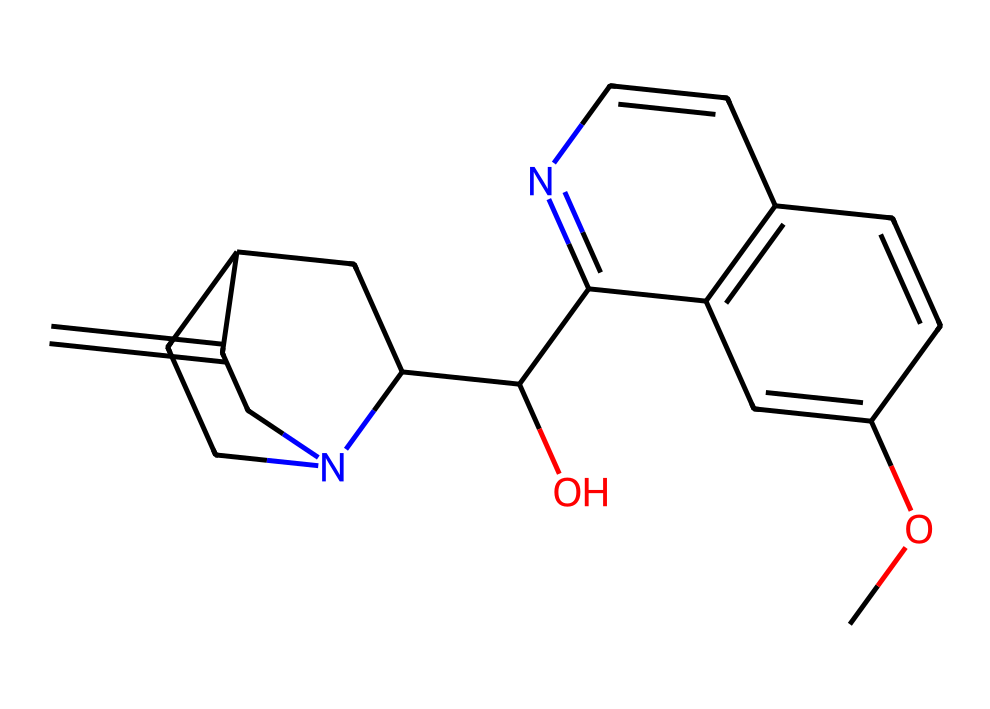What is the molecular formula for quinine? To find the molecular formula, we analyze the structure represented by the SMILES notation and count the number of each type of atom present in the molecule. The molecular formula of quinine is C20H24N2O2, which includes 20 carbon atoms, 24 hydrogen atoms, 2 nitrogen atoms, and 2 oxygen atoms.
Answer: C20H24N2O2 How many rings are present in the quinine structure? By examining the structure, we can identify the cyclic parts of the molecule. The SMILES indicates two distinct ring structures in quinine, which can be counted from the notation providing insight into its cyclic nature.
Answer: 2 What functional group is primarily responsible for quinine's bitterness? The presence of the nitrogen atom in the structure, characteristic of alkaloids, indicates the formation of a basic functional group that contributes to the bitterness of quinine.
Answer: Nitrogen What element is found in quinine that contributes to its pharmacological properties? In analyzing the structural formula through the SMILES representation, the nitrogen atoms play a critical role in its biological activity, affecting how quinine interacts with biological systems.
Answer: Nitrogen Which part of the molecule may enhance the solubility of quinine in beverages? The hydroxyl group (-OH) present in the molecular composition can significantly enhance solubility in polar solvents, enhancing the compound's overall behavior when added to beverages.
Answer: Hydroxyl group How many nitrogen atoms are present in quinine? By inspecting the SMILES representation closely, we can tally the total number of nitrogen atoms present, crucial for its classification as an alkaloid and its bitterness. There are two nitrogen atoms indicated in the structure.
Answer: 2 